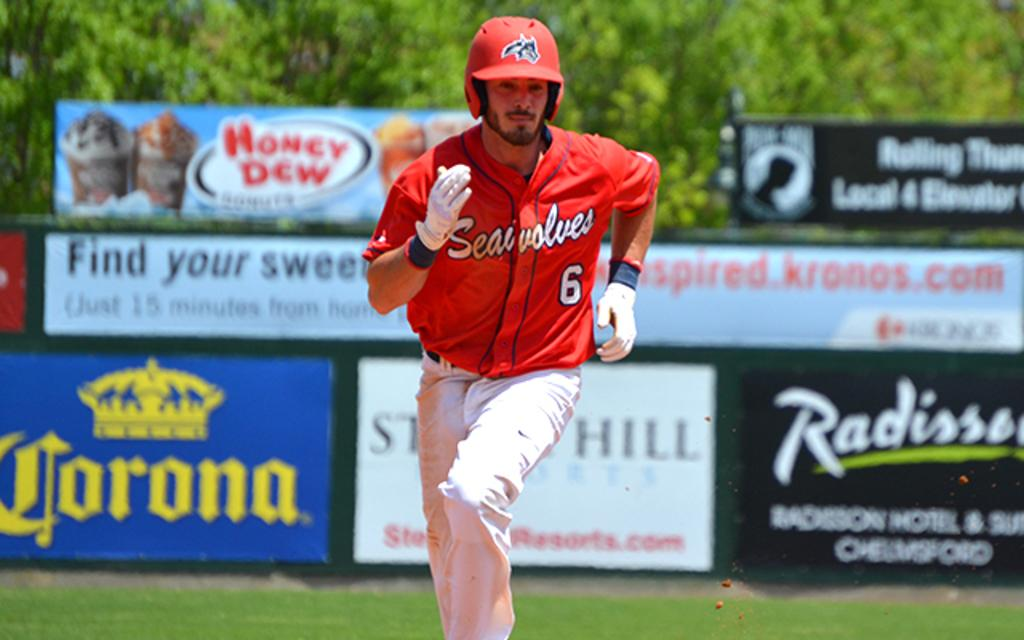<image>
Give a short and clear explanation of the subsequent image. Player number 6 runs the bases in front of a sign for Corona. 